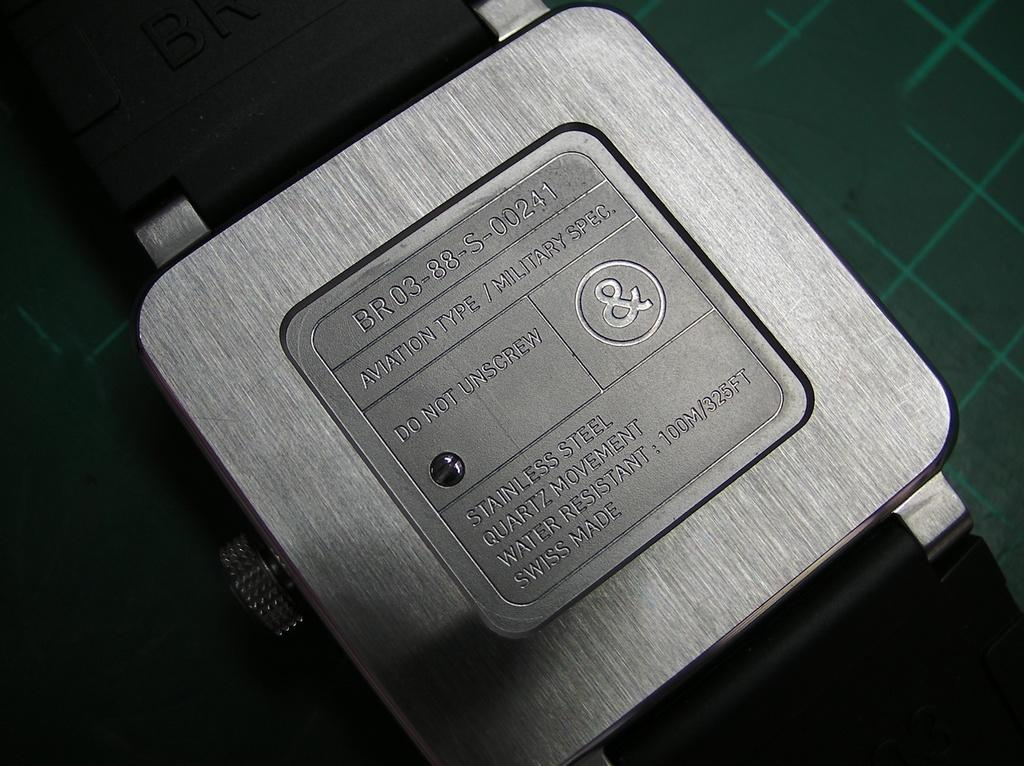<image>
Describe the image concisely. A watch is imprinted with the phrase "aviation type" and the serial number BR 03-88-S-00241. 